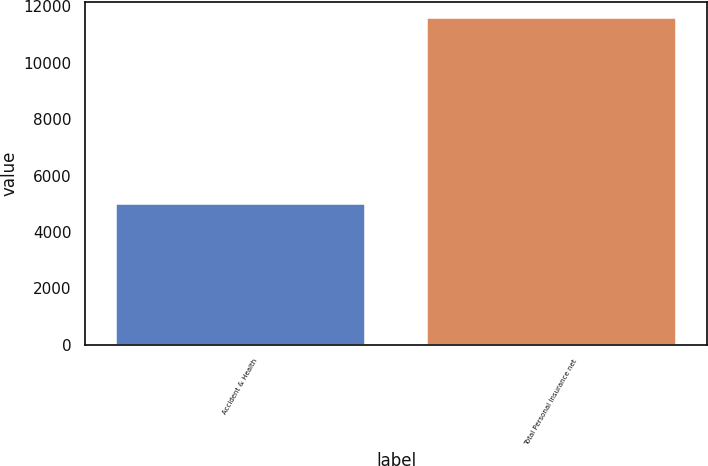<chart> <loc_0><loc_0><loc_500><loc_500><bar_chart><fcel>Accident & Health<fcel>Total Personal Insurance net<nl><fcel>4990<fcel>11580<nl></chart> 